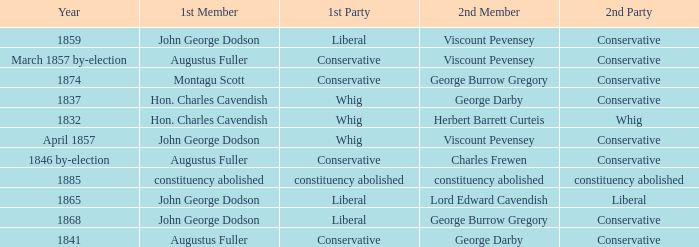In 1837, who was the 2nd member who's 2nd party was conservative. George Darby. 